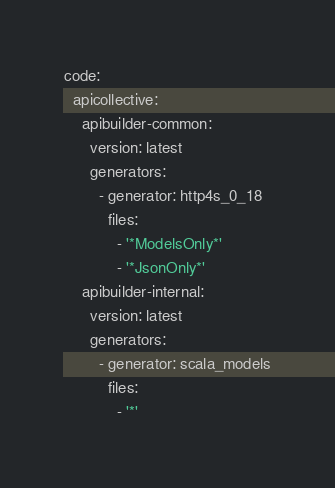<code> <loc_0><loc_0><loc_500><loc_500><_YAML_>code:
  apicollective:
    apibuilder-common:
      version: latest
      generators:
        - generator: http4s_0_18
          files:
            - '*ModelsOnly*'
            - '*JsonOnly*'
    apibuilder-internal:
      version: latest
      generators:
        - generator: scala_models
          files:
            - '*'
</code> 